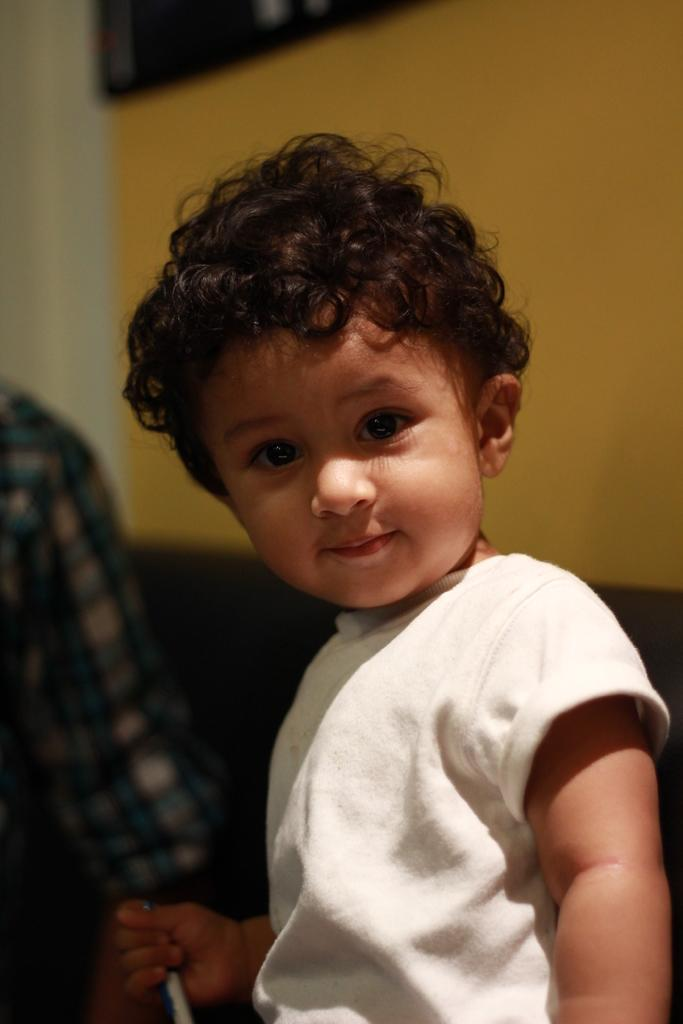What is present in the image? There is a child in the image. What is the child holding in the image? The child is holding an object. What can be seen in the background of the image? There is a wall visible in the image. What type of eggnog is the child's grandmother drinking in the image? There is no mention of eggnog or the child's grandmother in the image. What authority figure is present in the image? There is no authority figure present in the image. 